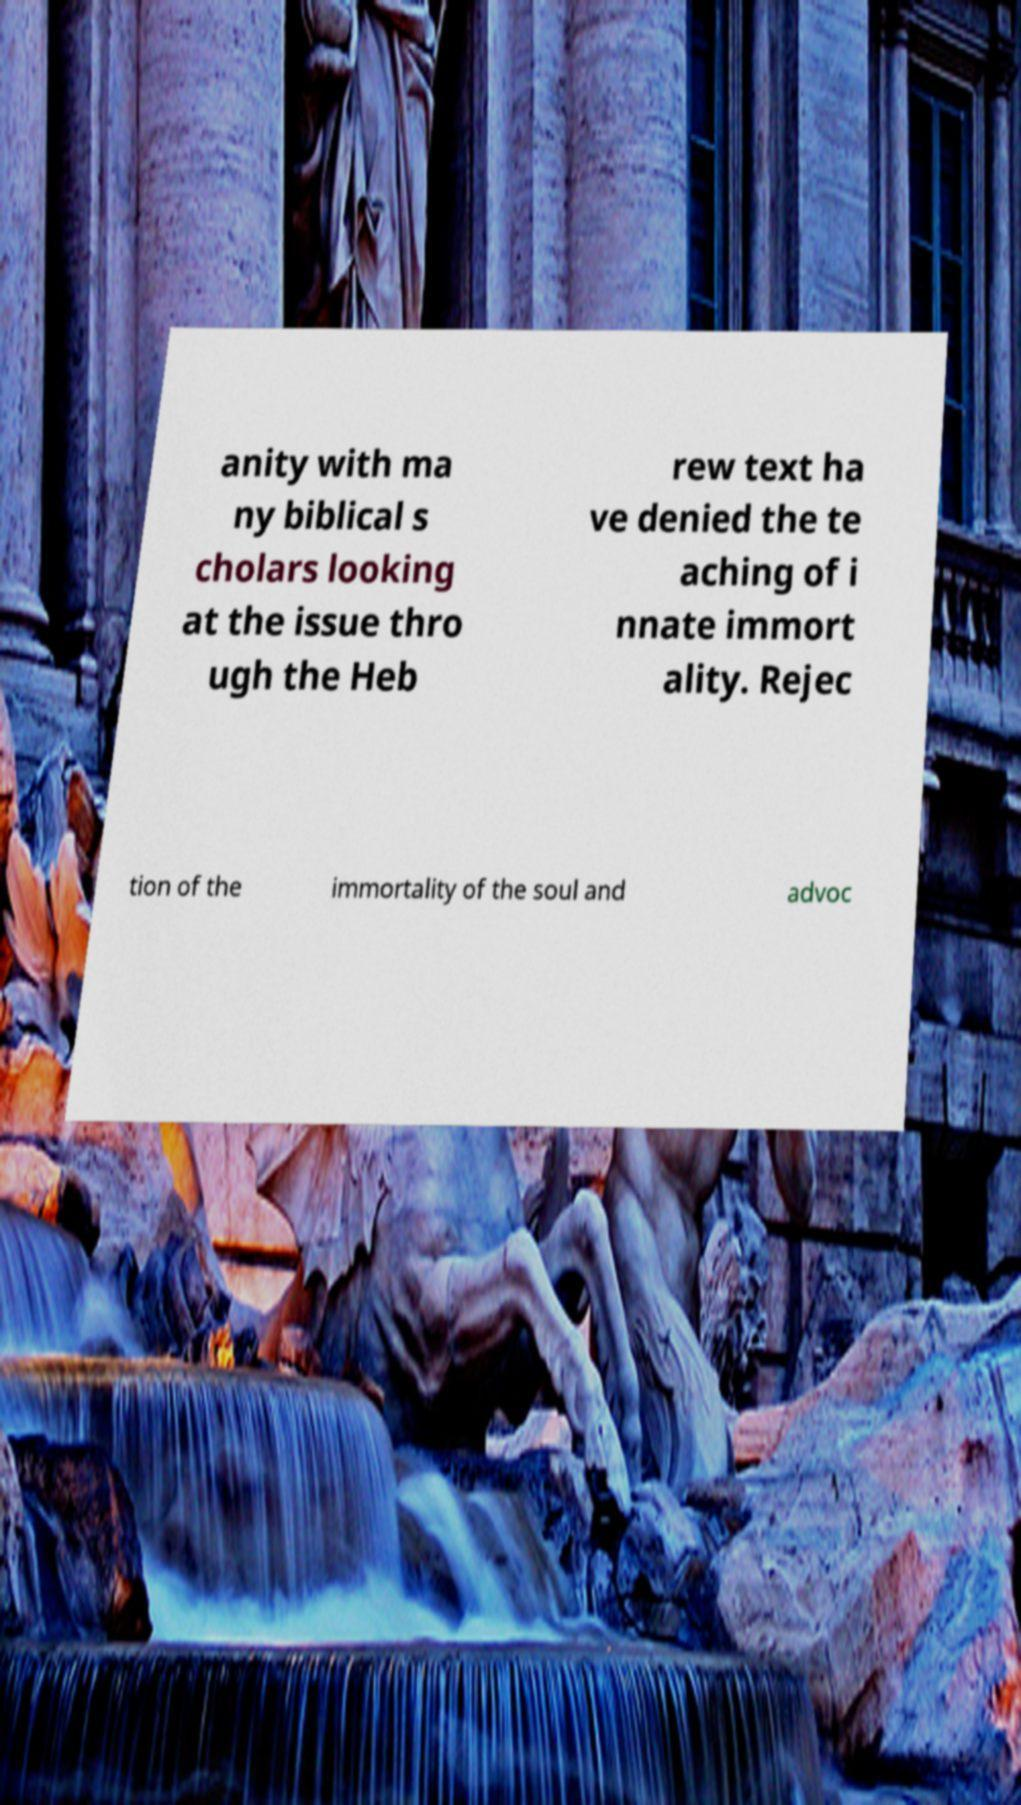For documentation purposes, I need the text within this image transcribed. Could you provide that? anity with ma ny biblical s cholars looking at the issue thro ugh the Heb rew text ha ve denied the te aching of i nnate immort ality. Rejec tion of the immortality of the soul and advoc 